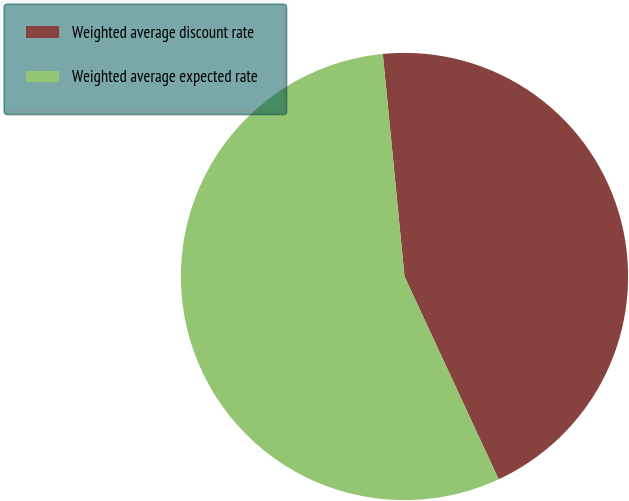Convert chart. <chart><loc_0><loc_0><loc_500><loc_500><pie_chart><fcel>Weighted average discount rate<fcel>Weighted average expected rate<nl><fcel>44.63%<fcel>55.37%<nl></chart> 